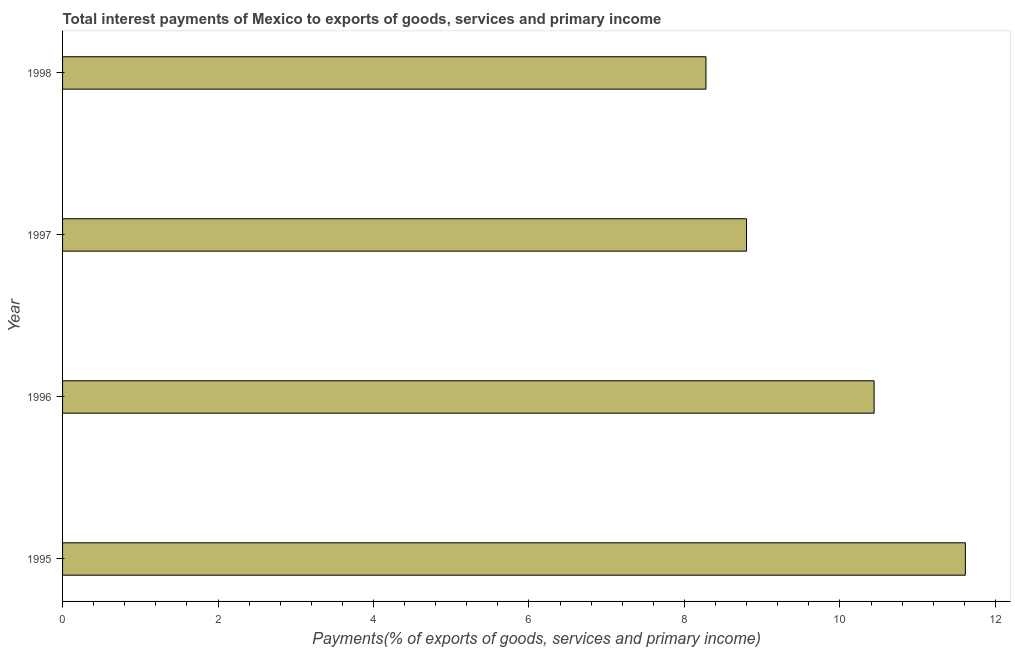Does the graph contain grids?
Make the answer very short. No. What is the title of the graph?
Offer a terse response. Total interest payments of Mexico to exports of goods, services and primary income. What is the label or title of the X-axis?
Provide a succinct answer. Payments(% of exports of goods, services and primary income). What is the total interest payments on external debt in 1996?
Give a very brief answer. 10.44. Across all years, what is the maximum total interest payments on external debt?
Provide a short and direct response. 11.61. Across all years, what is the minimum total interest payments on external debt?
Your answer should be very brief. 8.28. In which year was the total interest payments on external debt maximum?
Give a very brief answer. 1995. What is the sum of the total interest payments on external debt?
Give a very brief answer. 39.13. What is the difference between the total interest payments on external debt in 1995 and 1998?
Offer a very short reply. 3.34. What is the average total interest payments on external debt per year?
Ensure brevity in your answer.  9.78. What is the median total interest payments on external debt?
Give a very brief answer. 9.62. Do a majority of the years between 1995 and 1997 (inclusive) have total interest payments on external debt greater than 10.8 %?
Your response must be concise. No. What is the ratio of the total interest payments on external debt in 1995 to that in 1996?
Keep it short and to the point. 1.11. Is the total interest payments on external debt in 1996 less than that in 1997?
Offer a very short reply. No. Is the difference between the total interest payments on external debt in 1995 and 1997 greater than the difference between any two years?
Keep it short and to the point. No. What is the difference between the highest and the second highest total interest payments on external debt?
Your answer should be very brief. 1.17. Is the sum of the total interest payments on external debt in 1996 and 1998 greater than the maximum total interest payments on external debt across all years?
Your answer should be very brief. Yes. What is the difference between the highest and the lowest total interest payments on external debt?
Offer a terse response. 3.34. How many bars are there?
Provide a short and direct response. 4. What is the difference between two consecutive major ticks on the X-axis?
Offer a very short reply. 2. What is the Payments(% of exports of goods, services and primary income) of 1995?
Your response must be concise. 11.61. What is the Payments(% of exports of goods, services and primary income) in 1996?
Make the answer very short. 10.44. What is the Payments(% of exports of goods, services and primary income) in 1997?
Your answer should be compact. 8.8. What is the Payments(% of exports of goods, services and primary income) in 1998?
Ensure brevity in your answer.  8.28. What is the difference between the Payments(% of exports of goods, services and primary income) in 1995 and 1996?
Keep it short and to the point. 1.17. What is the difference between the Payments(% of exports of goods, services and primary income) in 1995 and 1997?
Make the answer very short. 2.81. What is the difference between the Payments(% of exports of goods, services and primary income) in 1995 and 1998?
Your response must be concise. 3.34. What is the difference between the Payments(% of exports of goods, services and primary income) in 1996 and 1997?
Offer a terse response. 1.64. What is the difference between the Payments(% of exports of goods, services and primary income) in 1996 and 1998?
Offer a very short reply. 2.16. What is the difference between the Payments(% of exports of goods, services and primary income) in 1997 and 1998?
Your response must be concise. 0.52. What is the ratio of the Payments(% of exports of goods, services and primary income) in 1995 to that in 1996?
Your answer should be very brief. 1.11. What is the ratio of the Payments(% of exports of goods, services and primary income) in 1995 to that in 1997?
Offer a terse response. 1.32. What is the ratio of the Payments(% of exports of goods, services and primary income) in 1995 to that in 1998?
Keep it short and to the point. 1.4. What is the ratio of the Payments(% of exports of goods, services and primary income) in 1996 to that in 1997?
Your answer should be very brief. 1.19. What is the ratio of the Payments(% of exports of goods, services and primary income) in 1996 to that in 1998?
Your answer should be compact. 1.26. What is the ratio of the Payments(% of exports of goods, services and primary income) in 1997 to that in 1998?
Give a very brief answer. 1.06. 